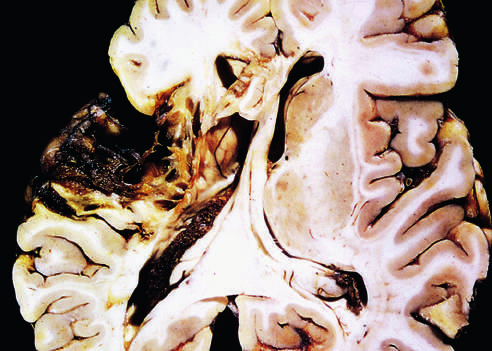does old cystic infarct show destruction of cortex and surrounding gliosis?
Answer the question using a single word or phrase. Yes 